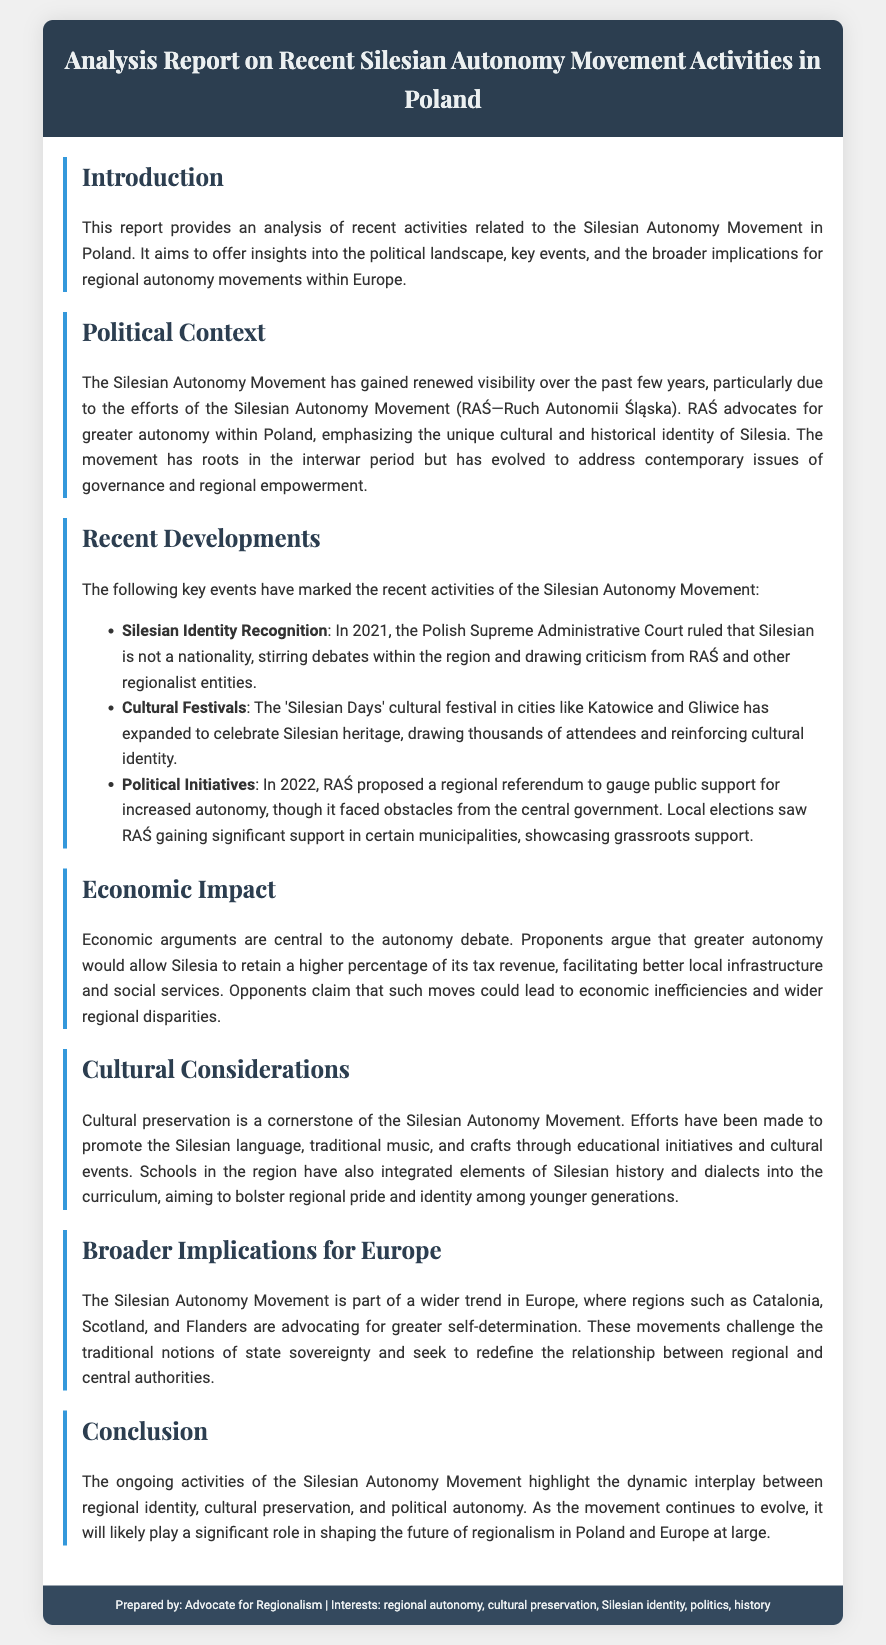what is the title of the report? The title of the report is prominently displayed in the header section of the document.
Answer: Analysis Report on Recent Silesian Autonomy Movement Activities in Poland who is the author of the report? The footer of the document indicates the prepared by section, which identifies the author.
Answer: Advocate for Regionalism what year did the Polish Supreme Administrative Court rule on Silesian nationality? The specific event and year are mentioned in the section about recent developments.
Answer: 2021 what is one cultural event mentioned in the report? The report lists cultural festivals in the context of the Silesian Autonomy Movement.
Answer: Silesian Days what proposal did RAŚ make in 2022? The document outlines key political initiatives proposed by RAŚ, particularly in the section on recent developments.
Answer: regional referendum how does the report characterize the economic arguments for autonomy? The content discusses the viewpoint of proponents and their arguments related to economic implications.
Answer: Retain tax revenue what are the broader implications of the Silesian Autonomy Movement for Europe? The report mentions the significance of the movement in relation to other regions in Europe.
Answer: Greater self-determination what is a focus of cultural preservation efforts mentioned in the report? The document specifies educational initiatives and cultural events related to Silesian heritage.
Answer: Silesian language how has the movement evolved historically according to the report? Information about the movement's historical roots is indicated in the political context section.
Answer: Interwar period 